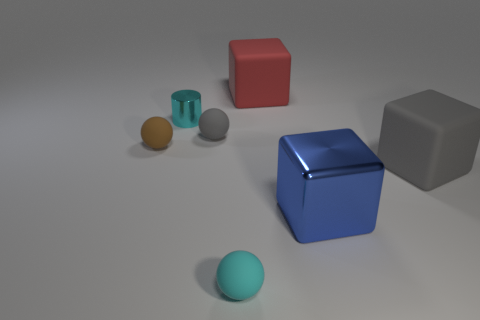Does the blue block have the same material as the cyan thing on the left side of the small gray rubber thing?
Give a very brief answer. Yes. Are there any other things that are the same shape as the brown thing?
Provide a succinct answer. Yes. Is the material of the big gray block the same as the cyan sphere?
Provide a succinct answer. Yes. There is a shiny object that is to the right of the small gray rubber ball; are there any small brown spheres right of it?
Provide a succinct answer. No. How many cubes are in front of the big gray object and behind the tiny cyan shiny cylinder?
Provide a succinct answer. 0. What is the shape of the matte thing that is right of the large red block?
Offer a terse response. Cube. How many spheres are the same size as the cyan metal cylinder?
Your response must be concise. 3. There is a large object behind the small gray matte thing; is it the same color as the shiny block?
Ensure brevity in your answer.  No. There is a thing that is both behind the brown ball and in front of the small cylinder; what material is it?
Make the answer very short. Rubber. Is the number of small red spheres greater than the number of cyan cylinders?
Make the answer very short. No. 